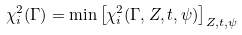Convert formula to latex. <formula><loc_0><loc_0><loc_500><loc_500>\chi _ { i } ^ { 2 } ( \Gamma ) = \min \left [ \chi _ { i } ^ { 2 } ( \Gamma , Z , t , \psi ) \right ] _ { Z , t , \psi }</formula> 